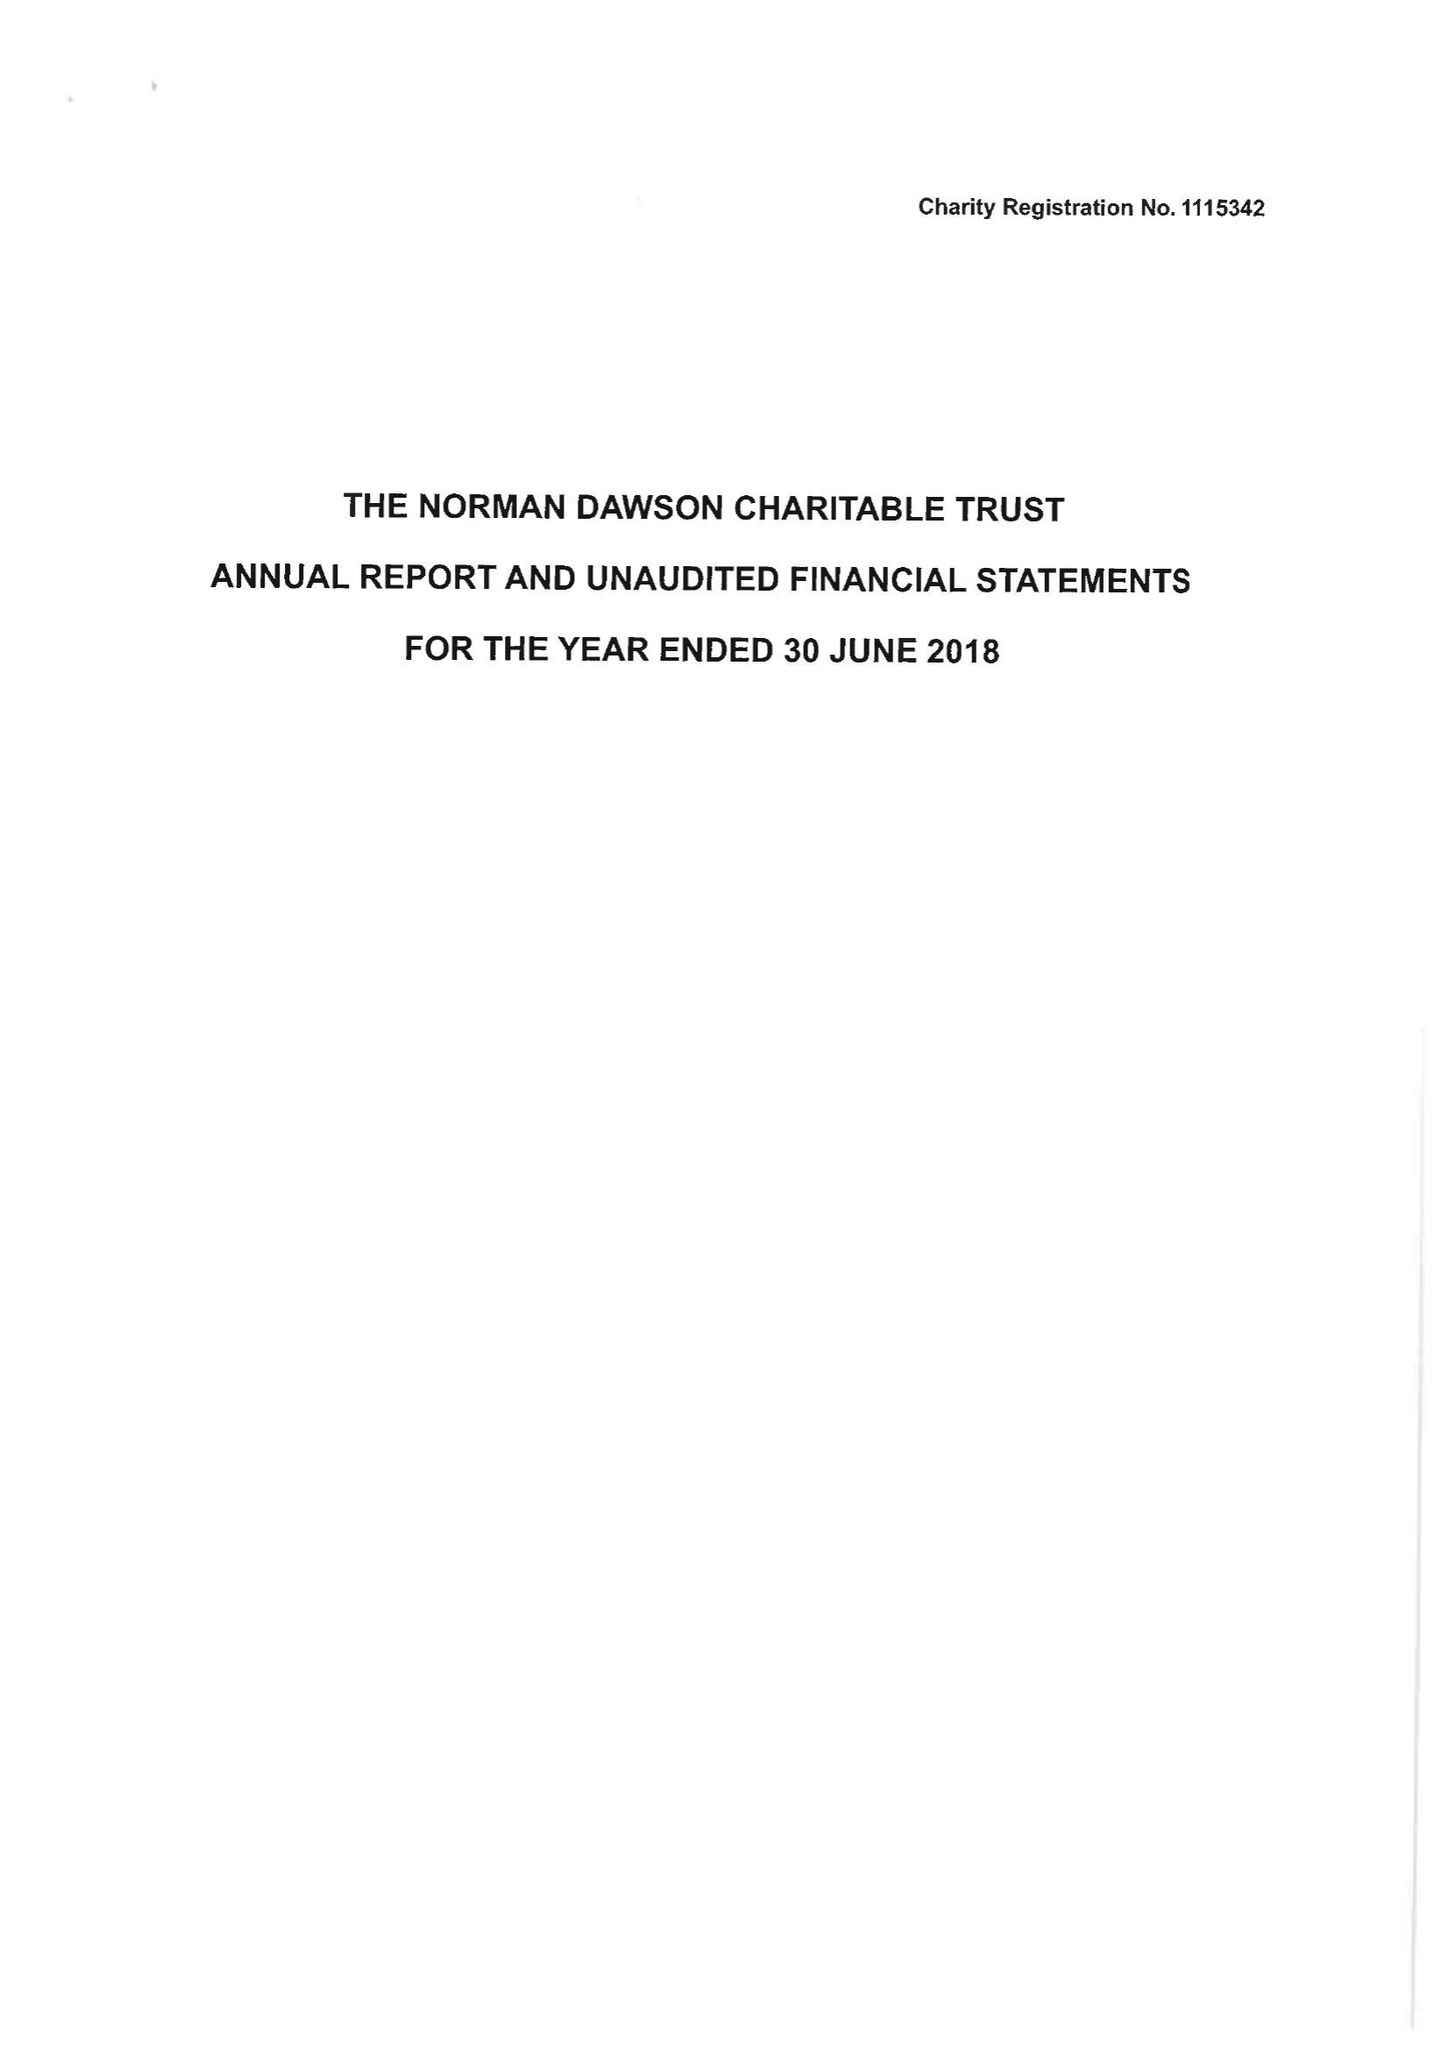What is the value for the charity_name?
Answer the question using a single word or phrase. The Norman Dawson Charitable Trust 